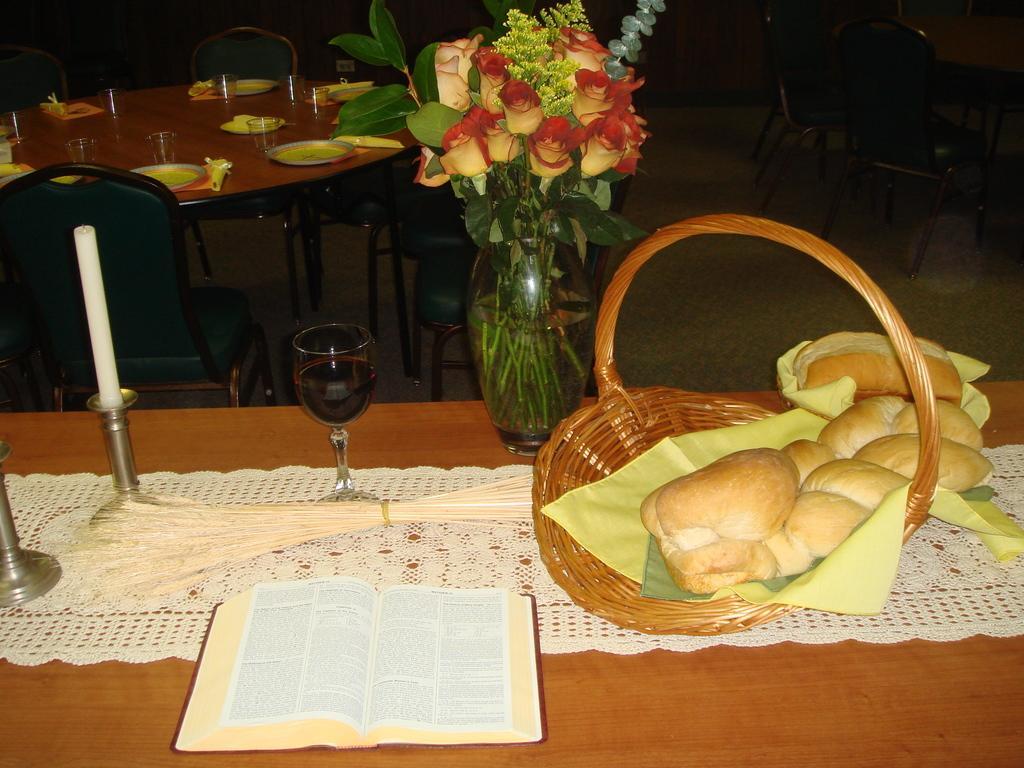How would you summarize this image in a sentence or two? This is the picture of a table on which there is a book, candle, glass and a basket, flower vase and also there is another table on which there are some plates and glasses and also some chairs in the room. 